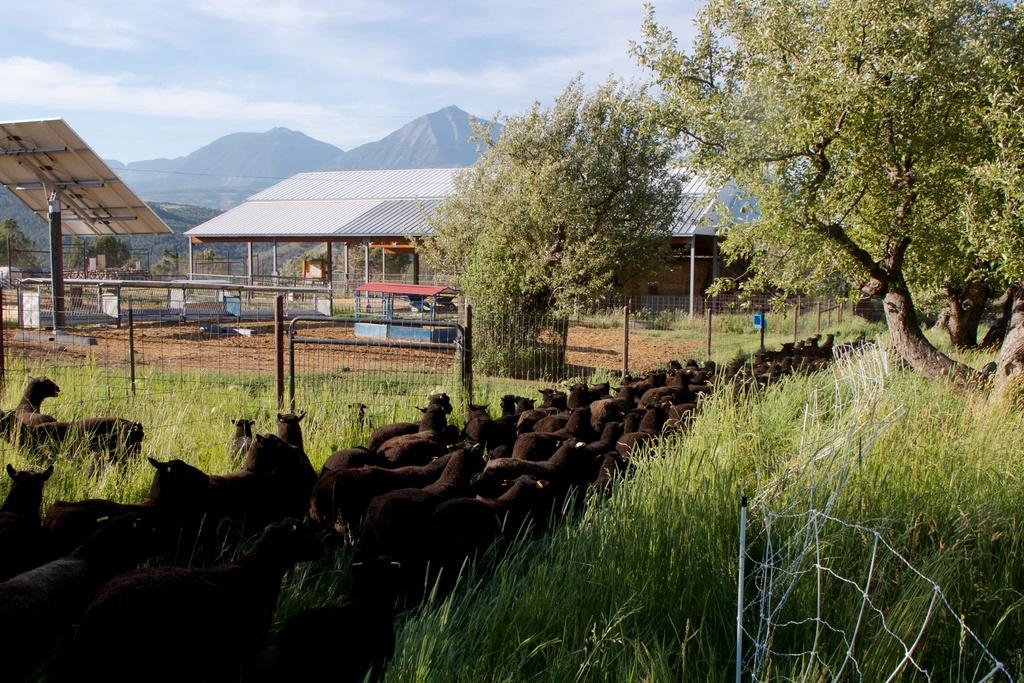What is the condition of the sky in the image? The sky is cloudy in the image. What type of structure can be seen in the image? There is an open shed in the image. What type of living organisms are present in the image? Animals are present in the image. What type of vegetation is visible in the image? Grass is visible in the image. What type of barrier is present in the image? There is a fence in the image. What type of natural feature is visible in the distance? There are mountains in the distance in the image. What object with a pole can be seen in the image? There is a board with a pole in the image. What type of doll is being used for scientific experiments in the image? There is no doll or scientific experiment present in the image. How does the rubbing of the animals affect the grass in the image? There is no rubbing of animals mentioned in the image, and therefore no effect on the grass can be determined. 